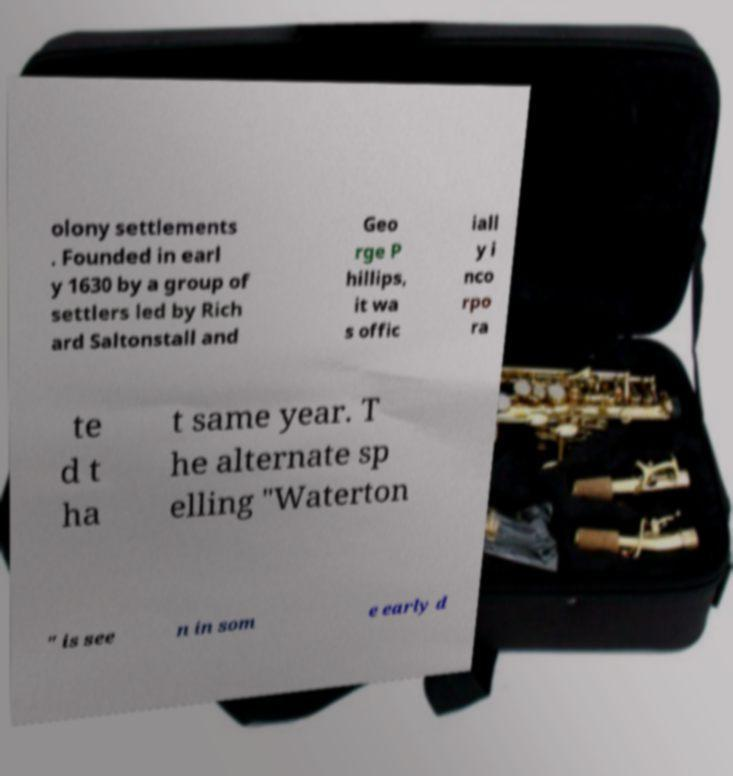Please read and relay the text visible in this image. What does it say? olony settlements . Founded in earl y 1630 by a group of settlers led by Rich ard Saltonstall and Geo rge P hillips, it wa s offic iall y i nco rpo ra te d t ha t same year. T he alternate sp elling "Waterton " is see n in som e early d 